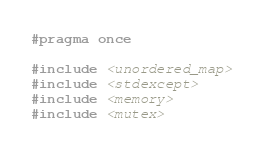<code> <loc_0><loc_0><loc_500><loc_500><_C++_>#pragma once

#include <unordered_map>
#include <stdexcept>
#include <memory>
#include <mutex></code> 